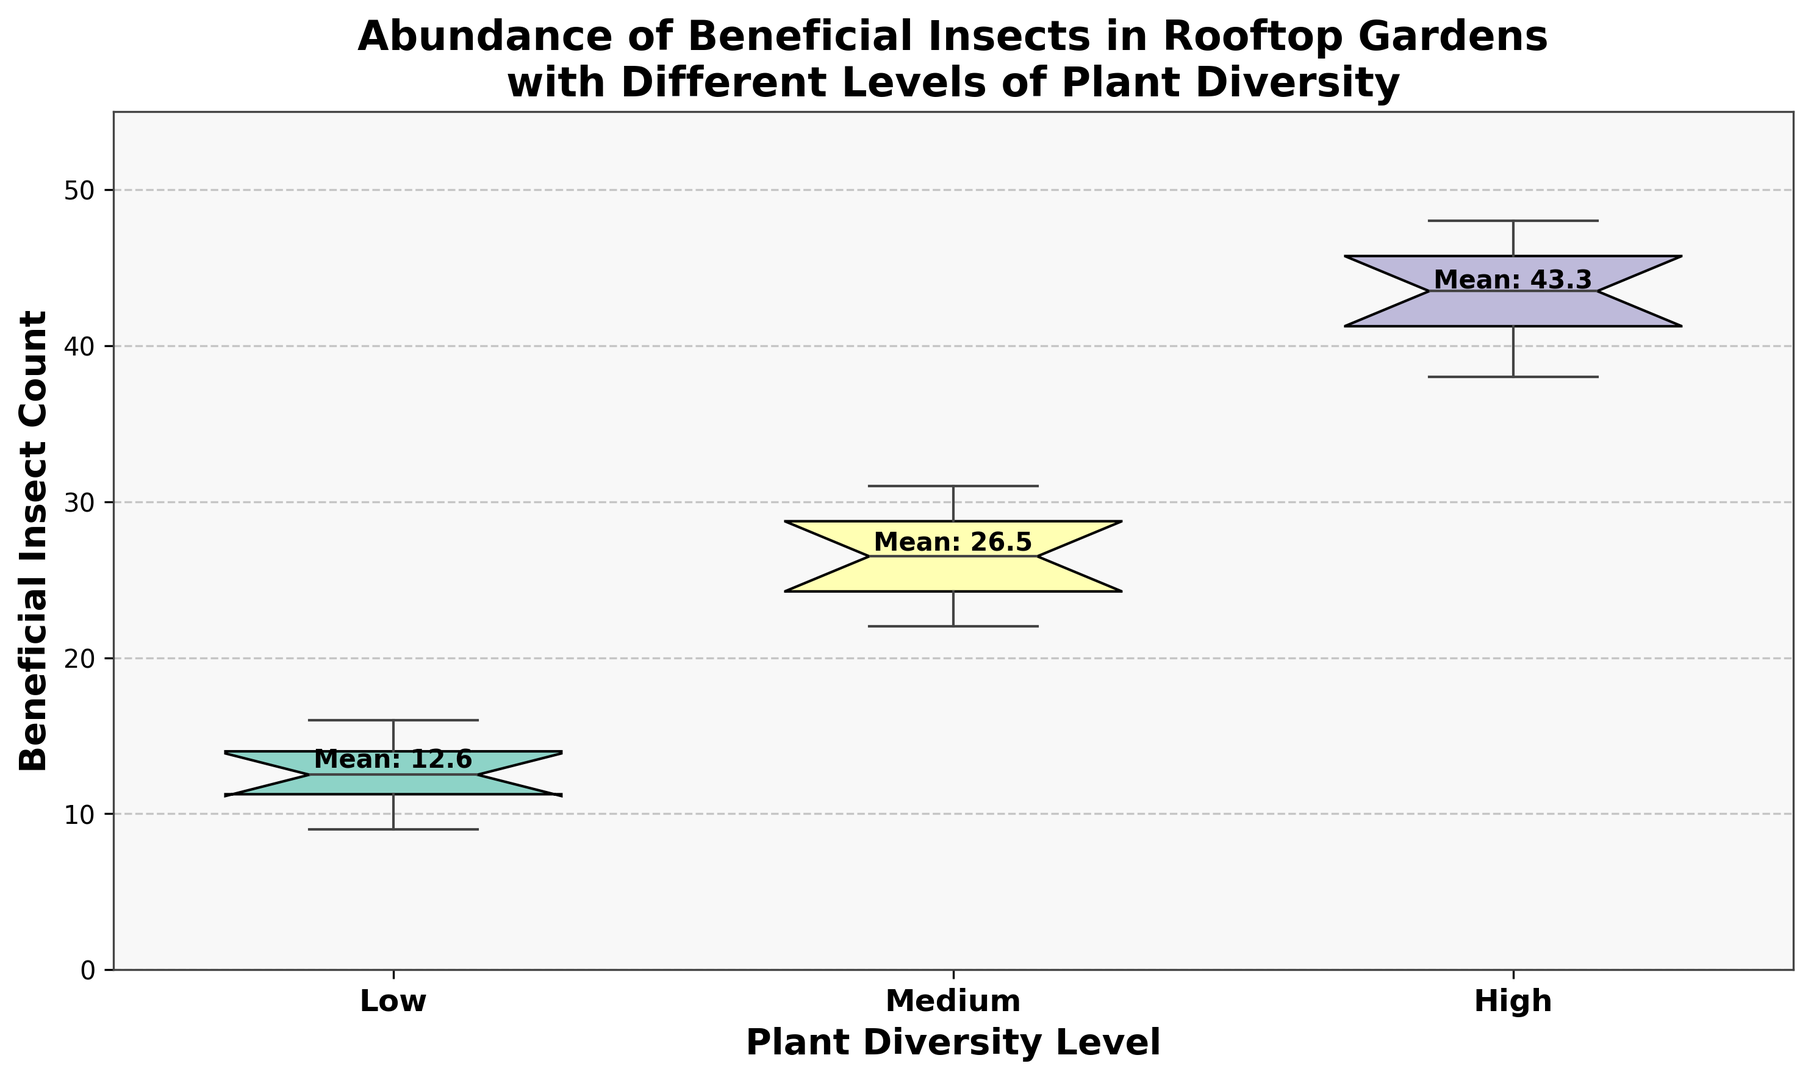What's the median insect count for each plant diversity level? For each plant diversity level (Low, Medium, High), look at the center line of the boxes in the box plot which represents the median values. The median values are 13 for Low, 27 for Medium, and 44 for High.
Answer: Low: 13, Medium: 27, High: 44 Which diversity level shows the highest variation in beneficial insect counts? Look at the range covered by each box and whiskers. High diversity exhibits the highest spread between the minimum and maximum values.
Answer: High What is the difference between the highest median insect count and the lowest median insect count? The difference is calculated by subtracting the median of the Low plant diversity level (13) from the median of the High plant diversity level (44): 44 - 13 = 31.
Answer: 31 Which diversity level has the smallest interquartile range (IQR) for beneficial insect counts? The IQR is the range between the first quartile (Q1) and the third quartile (Q3). By visually comparing the height of the boxes, the Low diversity level has the smallest IQR.
Answer: Low What are the mean insect counts for each diversity level? For each diversity level, the mean value is annotated above the respective boxes in the plot. The mean counts are 12.6 for Low, 26.5 for Medium, and 43.3 for High.
Answer: Low: 12.6, Medium: 26.5, High: 43.3 Comparing Low and Medium diversity levels, which one has a higher maximum insect count? The highest point (top whisker) of each box plot represents the maximum value. The Medium diversity level has a maximum insect count of 31, while the Low diversity level has a maximum of 16.
Answer: Medium How much higher is the upper quartile (Q3) of the High diversity level compared to the Medium diversity level? The third quartile (Q3) is the top edge of the box. Q3 for High is around 46, and Q3 for Medium is around 29. The difference is 46 - 29 = 17.
Answer: 17 Which diversity level has both fewer extreme values (outliers) and a lower maximum insect count? By observing the number of fliers and the top whisker, the Low diversity level has no extreme values and a lower maximum count of 16 compared to Medium and High diversity levels.
Answer: Low 